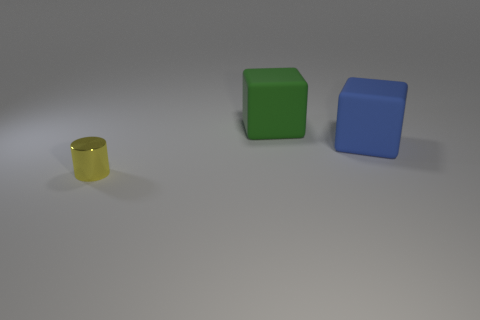Are there any other things that are the same size as the yellow thing?
Your answer should be very brief. No. What number of things are either objects that are behind the yellow cylinder or objects that are left of the green thing?
Provide a succinct answer. 3. Is the material of the large green thing the same as the object in front of the blue object?
Make the answer very short. No. What number of other objects are there of the same shape as the big green thing?
Provide a succinct answer. 1. There is a big cube to the right of the large matte block behind the large rubber object that is in front of the green rubber cube; what is it made of?
Your answer should be very brief. Rubber. Are there an equal number of green rubber cubes that are in front of the small yellow cylinder and tiny green cylinders?
Your answer should be very brief. Yes. Is the material of the thing that is behind the big blue rubber thing the same as the object in front of the blue cube?
Your response must be concise. No. Are there any other things that are the same material as the tiny cylinder?
Your answer should be compact. No. There is a big rubber thing in front of the green thing; is its shape the same as the large object behind the big blue thing?
Offer a terse response. Yes. Are there fewer metallic objects that are behind the yellow thing than tiny cyan matte cylinders?
Your answer should be compact. No. 